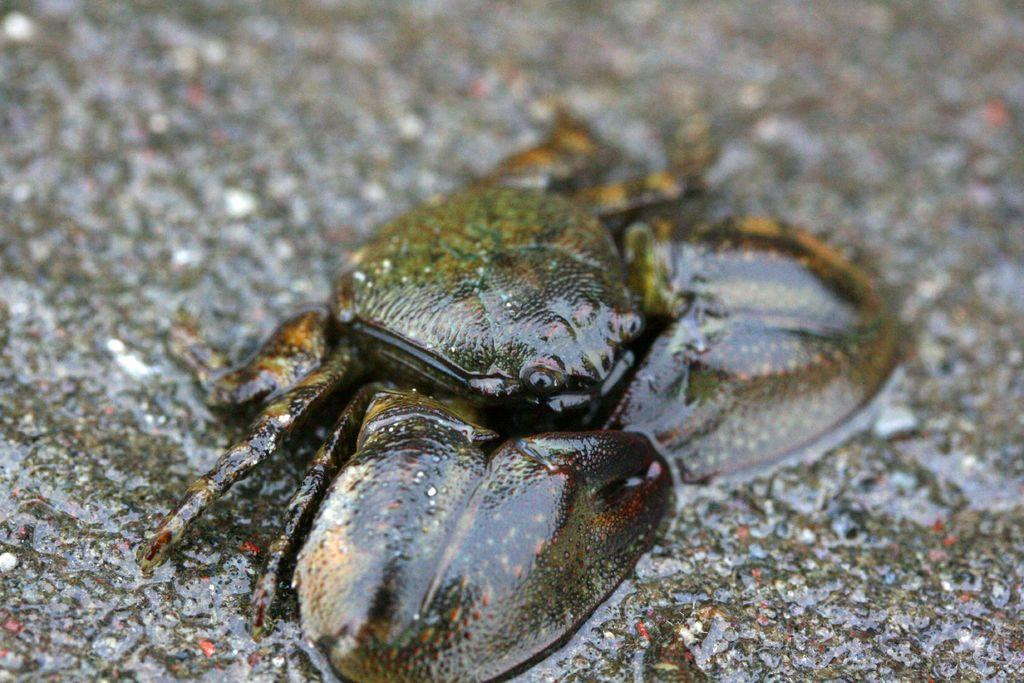What is the main subject in the center of the image? There is a reptile in the center of the image. What can be seen in the background of the image? There is a rock in the background of the image. How many oranges are being carried by the rat in the image? There is no rat or oranges present in the image. 